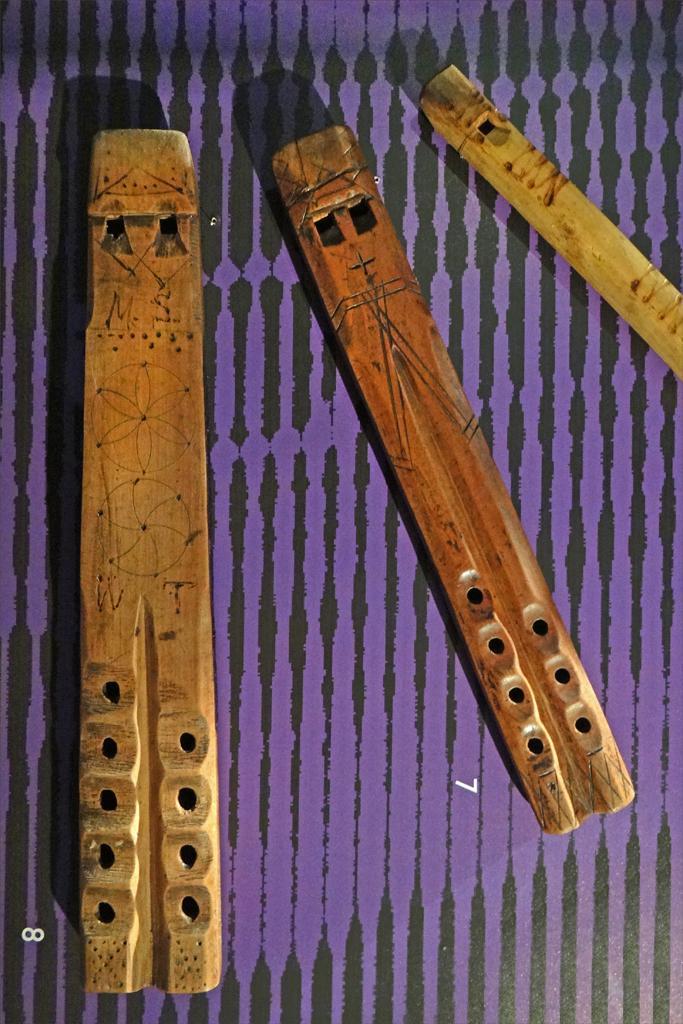In one or two sentences, can you explain what this image depicts? In this image I can see three flutes placed on an object which is violet in color and there are few black color lines on this. 